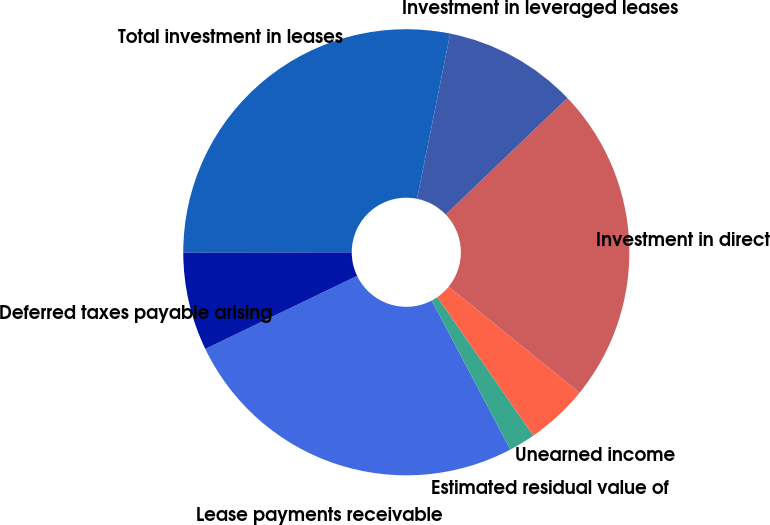Convert chart to OTSL. <chart><loc_0><loc_0><loc_500><loc_500><pie_chart><fcel>Lease payments receivable<fcel>Estimated residual value of<fcel>Unearned income<fcel>Investment in direct<fcel>Investment in leveraged leases<fcel>Total investment in leases<fcel>Deferred taxes payable arising<nl><fcel>25.59%<fcel>1.92%<fcel>4.51%<fcel>23.0%<fcel>9.69%<fcel>28.18%<fcel>7.1%<nl></chart> 